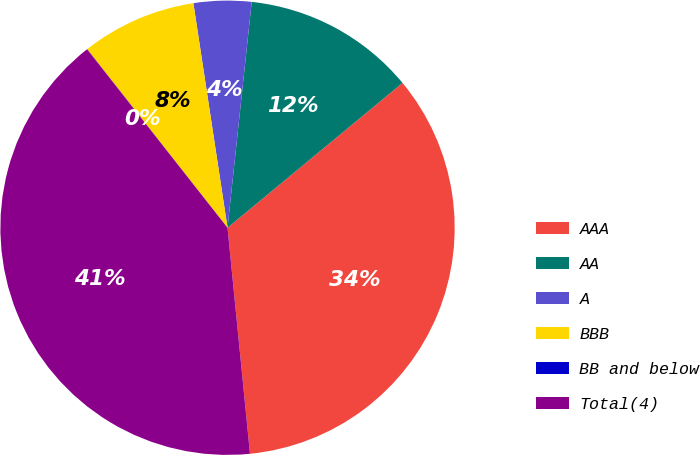<chart> <loc_0><loc_0><loc_500><loc_500><pie_chart><fcel>AAA<fcel>AA<fcel>A<fcel>BBB<fcel>BB and below<fcel>Total(4)<nl><fcel>34.43%<fcel>12.3%<fcel>4.1%<fcel>8.2%<fcel>0.01%<fcel>40.97%<nl></chart> 